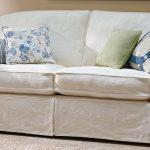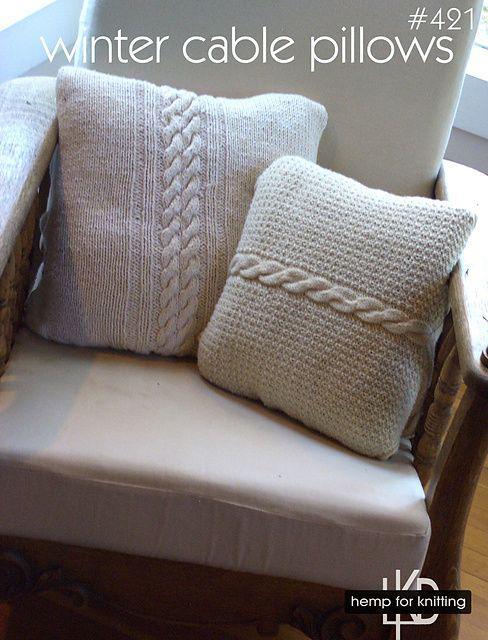The first image is the image on the left, the second image is the image on the right. Evaluate the accuracy of this statement regarding the images: "Each image shows a bed with non-white pillows on top and a dark head- and foot-board, displayed at an angle.". Is it true? Answer yes or no. No. 